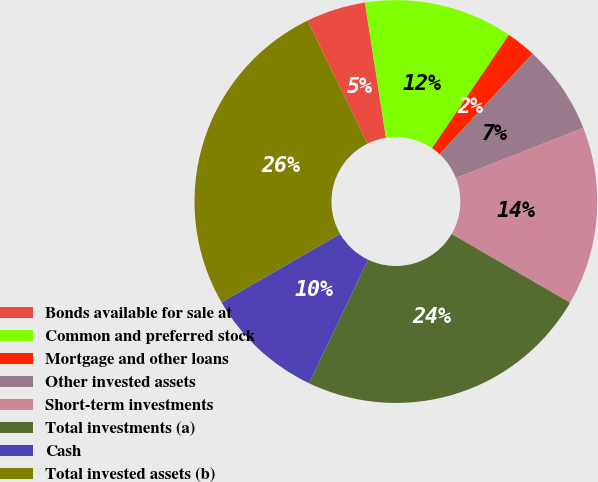Convert chart. <chart><loc_0><loc_0><loc_500><loc_500><pie_chart><fcel>Bonds available for sale at<fcel>Common and preferred stock<fcel>Mortgage and other loans<fcel>Other invested assets<fcel>Short-term investments<fcel>Total investments (a)<fcel>Cash<fcel>Total invested assets (b)<nl><fcel>4.78%<fcel>11.94%<fcel>2.39%<fcel>7.17%<fcel>14.33%<fcel>23.72%<fcel>9.56%<fcel>26.11%<nl></chart> 